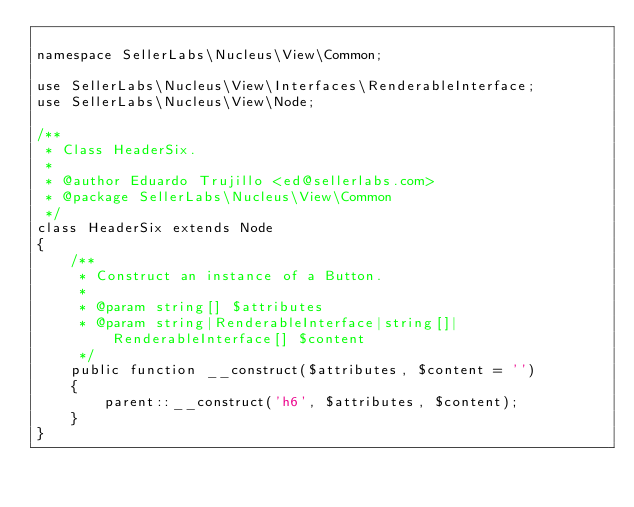Convert code to text. <code><loc_0><loc_0><loc_500><loc_500><_PHP_>
namespace SellerLabs\Nucleus\View\Common;

use SellerLabs\Nucleus\View\Interfaces\RenderableInterface;
use SellerLabs\Nucleus\View\Node;

/**
 * Class HeaderSix.
 *
 * @author Eduardo Trujillo <ed@sellerlabs.com>
 * @package SellerLabs\Nucleus\View\Common
 */
class HeaderSix extends Node
{
    /**
     * Construct an instance of a Button.
     *
     * @param string[] $attributes
     * @param string|RenderableInterface|string[]|RenderableInterface[] $content
     */
    public function __construct($attributes, $content = '')
    {
        parent::__construct('h6', $attributes, $content);
    }
}
</code> 